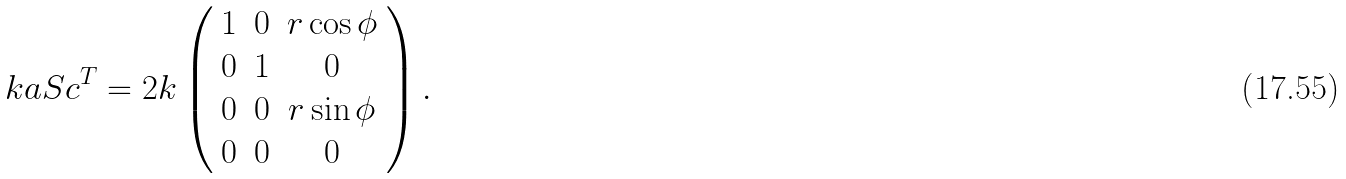Convert formula to latex. <formula><loc_0><loc_0><loc_500><loc_500>k a S c ^ { T } = 2 k \left ( \begin{array} { c c c } 1 & 0 & r \cos \phi \\ 0 & 1 & 0 \\ 0 & 0 & r \sin \phi \\ 0 & 0 & 0 \end{array} \right ) .</formula> 